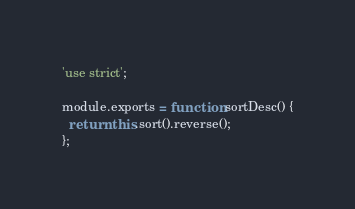Convert code to text. <code><loc_0><loc_0><loc_500><loc_500><_JavaScript_>'use strict';

module.exports = function sortDesc() {
  return this.sort().reverse();
};</code> 